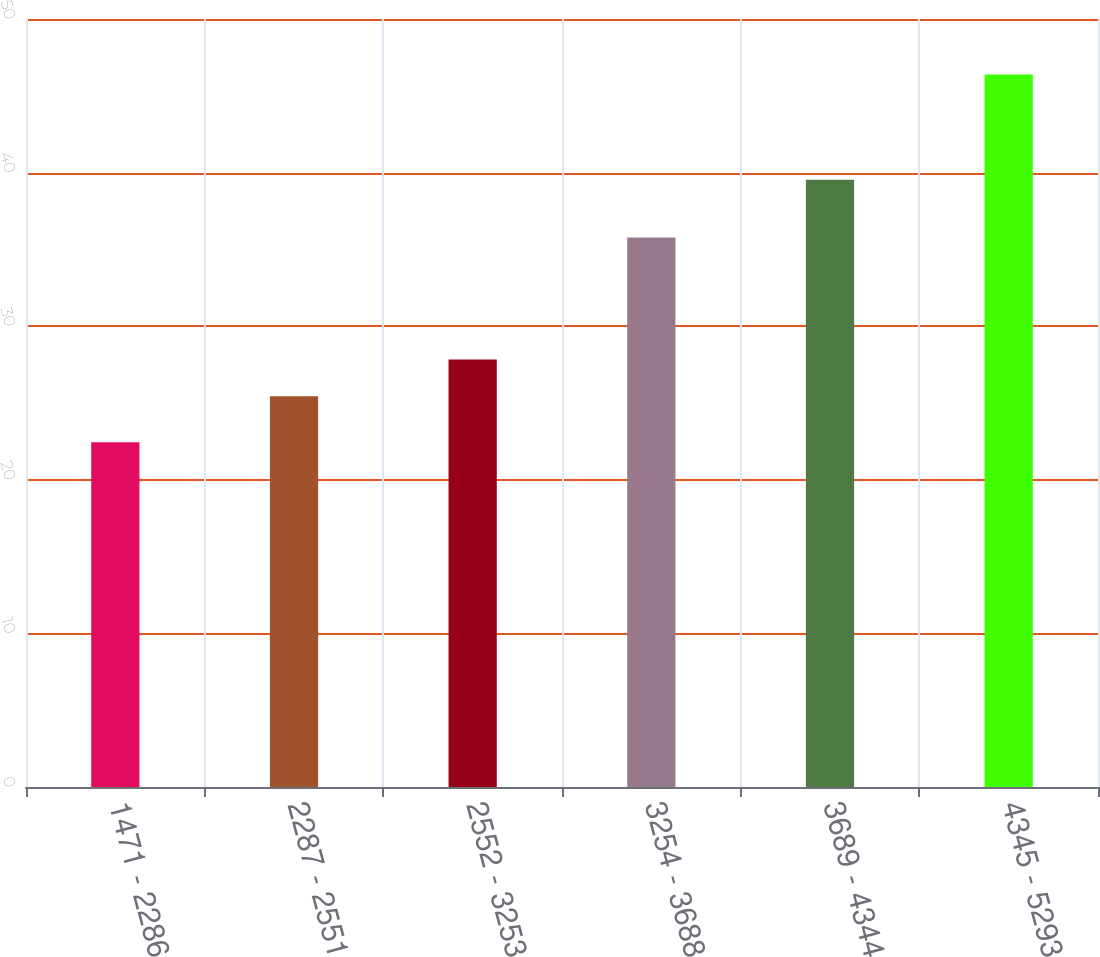Convert chart to OTSL. <chart><loc_0><loc_0><loc_500><loc_500><bar_chart><fcel>1471 - 2286<fcel>2287 - 2551<fcel>2552 - 3253<fcel>3254 - 3688<fcel>3689 - 4344<fcel>4345 - 5293<nl><fcel>22.45<fcel>25.44<fcel>27.83<fcel>35.77<fcel>39.54<fcel>46.38<nl></chart> 